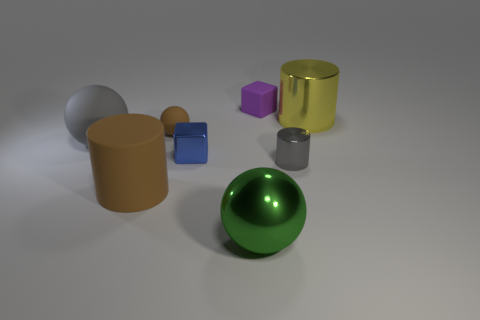What is the shape of the gray matte object to the left of the small metallic thing that is right of the tiny purple rubber block?
Provide a short and direct response. Sphere. Are there fewer small red objects than gray matte spheres?
Make the answer very short. Yes. There is a metallic cylinder that is to the left of the large shiny cylinder; what is its color?
Offer a terse response. Gray. There is a big thing that is both behind the large green ball and right of the small blue shiny object; what material is it?
Your answer should be compact. Metal. What is the shape of the blue object that is the same material as the tiny gray object?
Your response must be concise. Cube. How many large green objects are right of the shiny cylinder that is in front of the yellow shiny thing?
Your answer should be very brief. 0. What number of gray objects are both in front of the large gray thing and on the left side of the purple cube?
Ensure brevity in your answer.  0. What number of other objects are the same material as the large brown cylinder?
Make the answer very short. 3. What color is the big rubber object in front of the gray object that is on the left side of the big green sphere?
Your answer should be very brief. Brown. Do the large sphere in front of the gray ball and the tiny matte sphere have the same color?
Make the answer very short. No. 